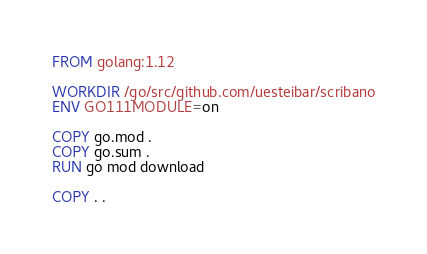<code> <loc_0><loc_0><loc_500><loc_500><_Dockerfile_>FROM golang:1.12

WORKDIR /go/src/github.com/uesteibar/scribano
ENV GO111MODULE=on

COPY go.mod .
COPY go.sum .
RUN go mod download

COPY . .

</code> 